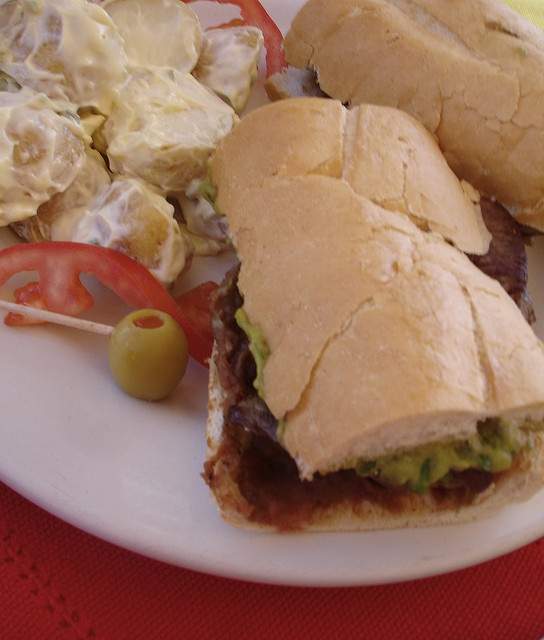Describe the objects in this image and their specific colors. I can see sandwich in darkgray, tan, gray, and maroon tones and sandwich in darkgray, gray, tan, brown, and maroon tones in this image. 